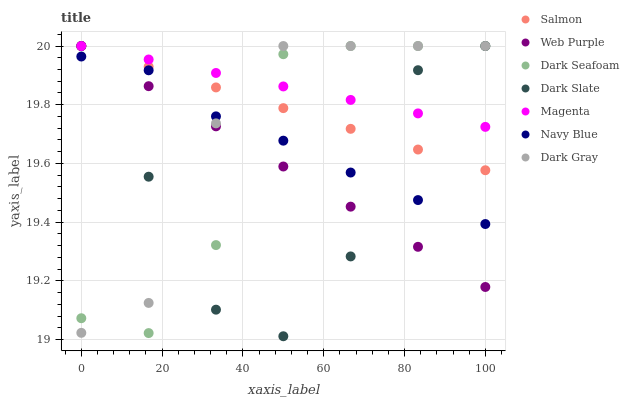Does Dark Slate have the minimum area under the curve?
Answer yes or no. Yes. Does Magenta have the maximum area under the curve?
Answer yes or no. Yes. Does Salmon have the minimum area under the curve?
Answer yes or no. No. Does Salmon have the maximum area under the curve?
Answer yes or no. No. Is Magenta the smoothest?
Answer yes or no. Yes. Is Dark Slate the roughest?
Answer yes or no. Yes. Is Salmon the smoothest?
Answer yes or no. No. Is Salmon the roughest?
Answer yes or no. No. Does Dark Slate have the lowest value?
Answer yes or no. Yes. Does Salmon have the lowest value?
Answer yes or no. No. Does Magenta have the highest value?
Answer yes or no. Yes. Is Navy Blue less than Magenta?
Answer yes or no. Yes. Is Salmon greater than Navy Blue?
Answer yes or no. Yes. Does Dark Seafoam intersect Dark Slate?
Answer yes or no. Yes. Is Dark Seafoam less than Dark Slate?
Answer yes or no. No. Is Dark Seafoam greater than Dark Slate?
Answer yes or no. No. Does Navy Blue intersect Magenta?
Answer yes or no. No. 